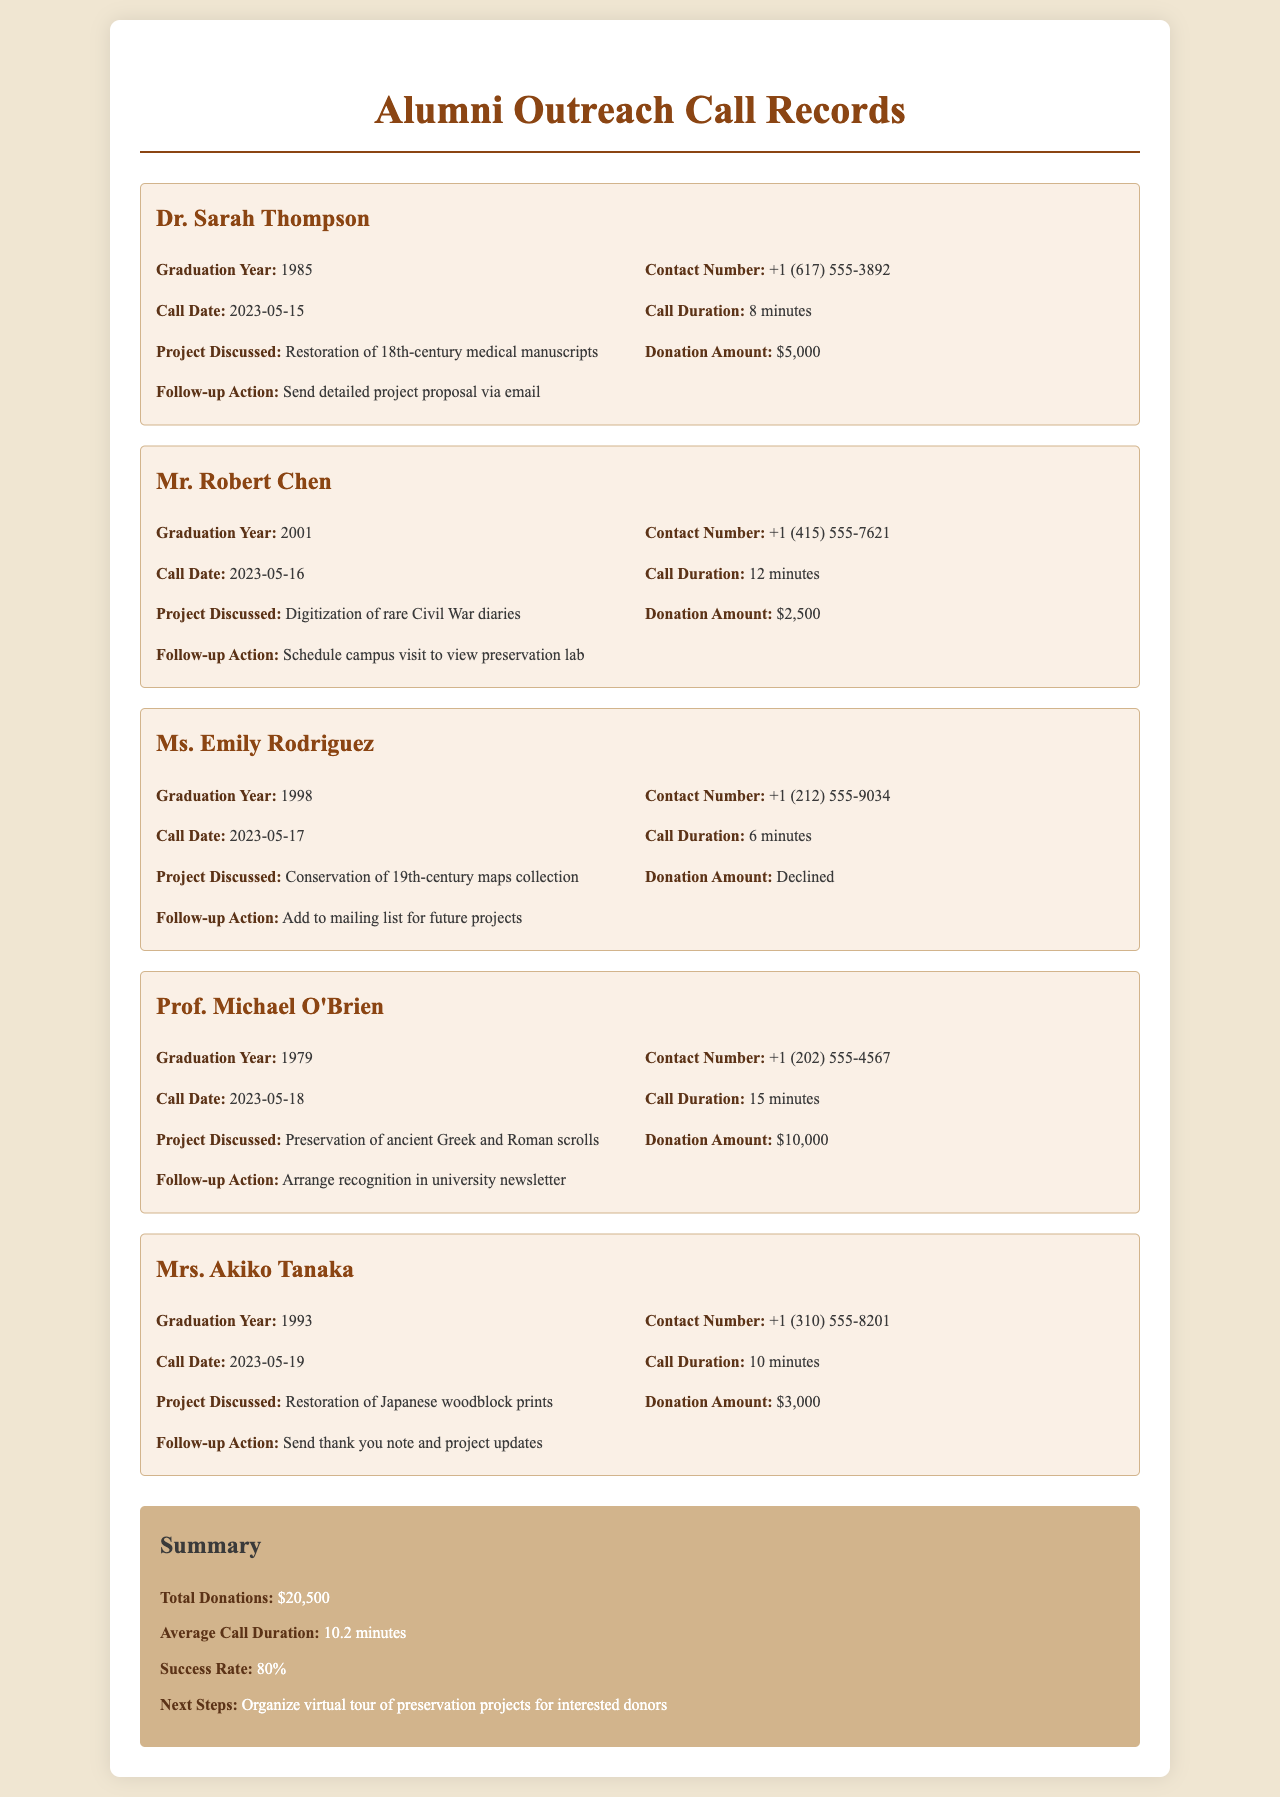What is the total amount of donations received? The total amount of donations is found in the summary section, which lists the total donations as $20,500.
Answer: $20,500 What is the duration of Dr. Sarah Thompson's call? The duration of the call with Dr. Sarah Thompson can be found in the details for her call record, which states it was 8 minutes.
Answer: 8 minutes What project did Mr. Robert Chen donate to? Mr. Robert Chen's project discussed during the call is indicated as the digitization of rare Civil War diaries.
Answer: Digitization of rare Civil War diaries What is the follow-up action for Ms. Emily Rodriguez? The follow-up action for Ms. Emily Rodriguez is mentioned as adding her to the mailing list for future projects, found in her call record.
Answer: Add to mailing list for future projects What was the average call duration? The average call duration can be seen in the summary section, where it is calculated as 10.2 minutes.
Answer: 10.2 minutes What is the success rate of the outreach calls? The success rate is listed in the summary, indicating that 80% of the calls were successful.
Answer: 80% Which alumni contributed $10,000? The alumni who donated $10,000 is specified as Prof. Michael O'Brien in his call record.
Answer: Prof. Michael O'Brien What year did Mrs. Akiko Tanaka graduate? Mrs. Akiko Tanaka's graduation year is noted in her call record, which is 1993.
Answer: 1993 What action should be taken next for interested donors? The next step outlined in the summary for interested donors is to organize a virtual tour of preservation projects.
Answer: Organize virtual tour of preservation projects 